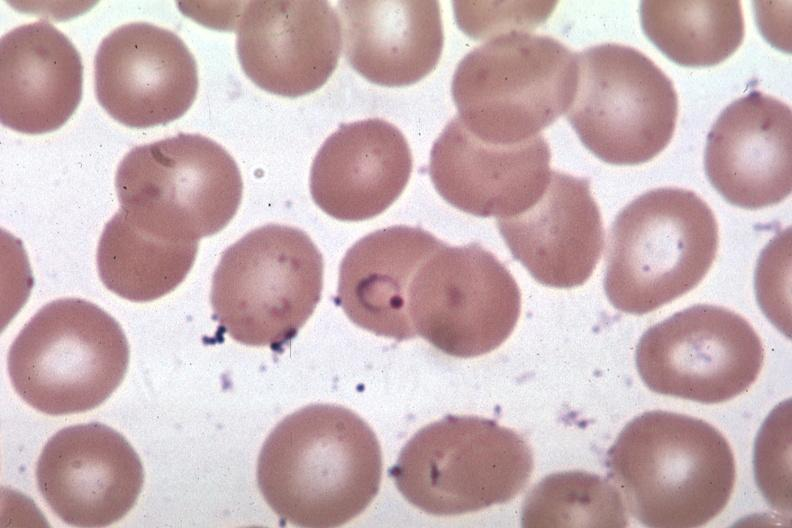s acute myelogenous leukemia present?
Answer the question using a single word or phrase. No 